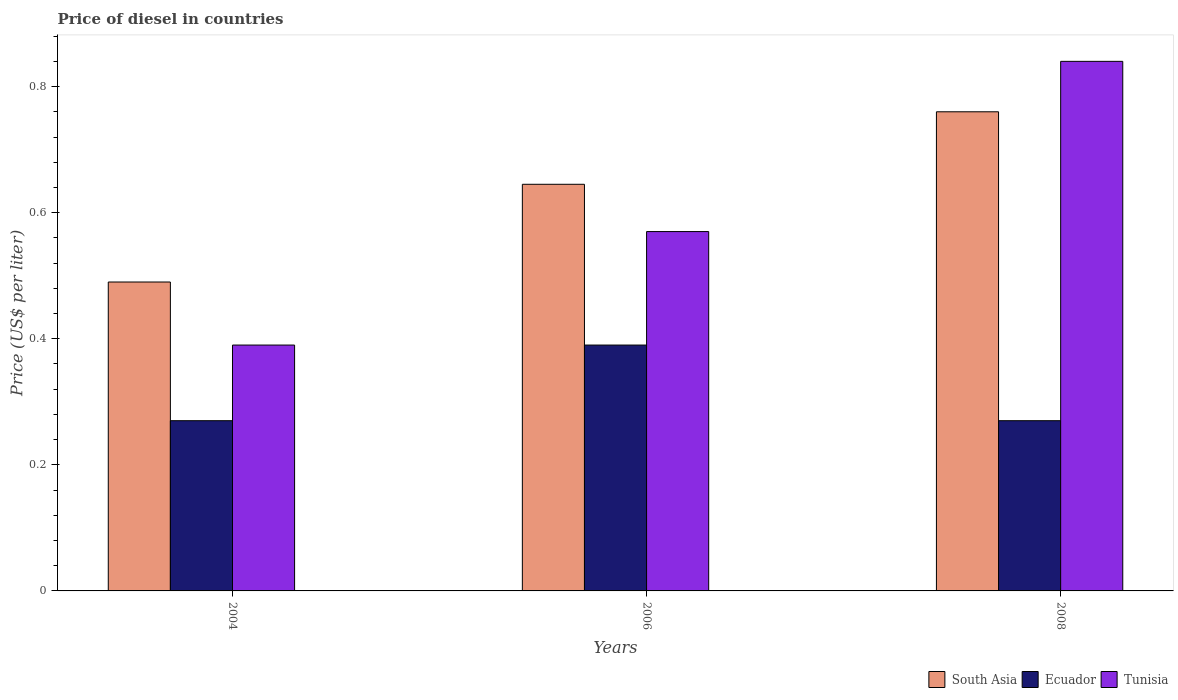How many different coloured bars are there?
Offer a terse response. 3. How many groups of bars are there?
Provide a succinct answer. 3. How many bars are there on the 1st tick from the left?
Keep it short and to the point. 3. What is the label of the 3rd group of bars from the left?
Your answer should be compact. 2008. What is the price of diesel in Ecuador in 2008?
Provide a succinct answer. 0.27. Across all years, what is the maximum price of diesel in Ecuador?
Provide a short and direct response. 0.39. Across all years, what is the minimum price of diesel in South Asia?
Keep it short and to the point. 0.49. In which year was the price of diesel in Tunisia maximum?
Offer a very short reply. 2008. In which year was the price of diesel in South Asia minimum?
Offer a very short reply. 2004. What is the total price of diesel in Ecuador in the graph?
Give a very brief answer. 0.93. What is the difference between the price of diesel in Ecuador in 2004 and that in 2006?
Offer a very short reply. -0.12. What is the difference between the price of diesel in South Asia in 2006 and the price of diesel in Tunisia in 2004?
Provide a short and direct response. 0.26. What is the average price of diesel in Tunisia per year?
Give a very brief answer. 0.6. In the year 2006, what is the difference between the price of diesel in South Asia and price of diesel in Tunisia?
Offer a very short reply. 0.08. In how many years, is the price of diesel in Ecuador greater than 0.28 US$?
Provide a short and direct response. 1. What is the ratio of the price of diesel in Tunisia in 2004 to that in 2006?
Provide a short and direct response. 0.68. What is the difference between the highest and the second highest price of diesel in Tunisia?
Provide a succinct answer. 0.27. What is the difference between the highest and the lowest price of diesel in Tunisia?
Provide a succinct answer. 0.45. Is the sum of the price of diesel in South Asia in 2004 and 2006 greater than the maximum price of diesel in Ecuador across all years?
Provide a succinct answer. Yes. What does the 3rd bar from the left in 2004 represents?
Offer a terse response. Tunisia. What does the 1st bar from the right in 2008 represents?
Your response must be concise. Tunisia. What is the difference between two consecutive major ticks on the Y-axis?
Provide a short and direct response. 0.2. Are the values on the major ticks of Y-axis written in scientific E-notation?
Make the answer very short. No. Does the graph contain grids?
Your response must be concise. No. What is the title of the graph?
Your answer should be compact. Price of diesel in countries. Does "Dominican Republic" appear as one of the legend labels in the graph?
Ensure brevity in your answer.  No. What is the label or title of the Y-axis?
Your answer should be compact. Price (US$ per liter). What is the Price (US$ per liter) of South Asia in 2004?
Ensure brevity in your answer.  0.49. What is the Price (US$ per liter) in Ecuador in 2004?
Give a very brief answer. 0.27. What is the Price (US$ per liter) in Tunisia in 2004?
Keep it short and to the point. 0.39. What is the Price (US$ per liter) of South Asia in 2006?
Your answer should be very brief. 0.65. What is the Price (US$ per liter) of Ecuador in 2006?
Your answer should be compact. 0.39. What is the Price (US$ per liter) in Tunisia in 2006?
Your answer should be very brief. 0.57. What is the Price (US$ per liter) of South Asia in 2008?
Ensure brevity in your answer.  0.76. What is the Price (US$ per liter) in Ecuador in 2008?
Offer a terse response. 0.27. What is the Price (US$ per liter) in Tunisia in 2008?
Give a very brief answer. 0.84. Across all years, what is the maximum Price (US$ per liter) of South Asia?
Your answer should be compact. 0.76. Across all years, what is the maximum Price (US$ per liter) of Ecuador?
Keep it short and to the point. 0.39. Across all years, what is the maximum Price (US$ per liter) of Tunisia?
Ensure brevity in your answer.  0.84. Across all years, what is the minimum Price (US$ per liter) of South Asia?
Your response must be concise. 0.49. Across all years, what is the minimum Price (US$ per liter) in Ecuador?
Offer a terse response. 0.27. Across all years, what is the minimum Price (US$ per liter) of Tunisia?
Your response must be concise. 0.39. What is the total Price (US$ per liter) of South Asia in the graph?
Offer a very short reply. 1.9. What is the total Price (US$ per liter) in Ecuador in the graph?
Offer a very short reply. 0.93. What is the total Price (US$ per liter) of Tunisia in the graph?
Provide a succinct answer. 1.8. What is the difference between the Price (US$ per liter) in South Asia in 2004 and that in 2006?
Make the answer very short. -0.15. What is the difference between the Price (US$ per liter) of Ecuador in 2004 and that in 2006?
Ensure brevity in your answer.  -0.12. What is the difference between the Price (US$ per liter) of Tunisia in 2004 and that in 2006?
Ensure brevity in your answer.  -0.18. What is the difference between the Price (US$ per liter) of South Asia in 2004 and that in 2008?
Offer a terse response. -0.27. What is the difference between the Price (US$ per liter) of Tunisia in 2004 and that in 2008?
Offer a terse response. -0.45. What is the difference between the Price (US$ per liter) in South Asia in 2006 and that in 2008?
Offer a very short reply. -0.12. What is the difference between the Price (US$ per liter) in Ecuador in 2006 and that in 2008?
Provide a succinct answer. 0.12. What is the difference between the Price (US$ per liter) in Tunisia in 2006 and that in 2008?
Make the answer very short. -0.27. What is the difference between the Price (US$ per liter) of South Asia in 2004 and the Price (US$ per liter) of Ecuador in 2006?
Give a very brief answer. 0.1. What is the difference between the Price (US$ per liter) in South Asia in 2004 and the Price (US$ per liter) in Tunisia in 2006?
Give a very brief answer. -0.08. What is the difference between the Price (US$ per liter) of South Asia in 2004 and the Price (US$ per liter) of Ecuador in 2008?
Offer a very short reply. 0.22. What is the difference between the Price (US$ per liter) of South Asia in 2004 and the Price (US$ per liter) of Tunisia in 2008?
Offer a terse response. -0.35. What is the difference between the Price (US$ per liter) of Ecuador in 2004 and the Price (US$ per liter) of Tunisia in 2008?
Give a very brief answer. -0.57. What is the difference between the Price (US$ per liter) of South Asia in 2006 and the Price (US$ per liter) of Tunisia in 2008?
Make the answer very short. -0.2. What is the difference between the Price (US$ per liter) in Ecuador in 2006 and the Price (US$ per liter) in Tunisia in 2008?
Your response must be concise. -0.45. What is the average Price (US$ per liter) of South Asia per year?
Give a very brief answer. 0.63. What is the average Price (US$ per liter) of Ecuador per year?
Provide a succinct answer. 0.31. In the year 2004, what is the difference between the Price (US$ per liter) in South Asia and Price (US$ per liter) in Ecuador?
Your answer should be compact. 0.22. In the year 2004, what is the difference between the Price (US$ per liter) of South Asia and Price (US$ per liter) of Tunisia?
Ensure brevity in your answer.  0.1. In the year 2004, what is the difference between the Price (US$ per liter) in Ecuador and Price (US$ per liter) in Tunisia?
Provide a succinct answer. -0.12. In the year 2006, what is the difference between the Price (US$ per liter) in South Asia and Price (US$ per liter) in Ecuador?
Your answer should be compact. 0.26. In the year 2006, what is the difference between the Price (US$ per liter) of South Asia and Price (US$ per liter) of Tunisia?
Make the answer very short. 0.07. In the year 2006, what is the difference between the Price (US$ per liter) of Ecuador and Price (US$ per liter) of Tunisia?
Keep it short and to the point. -0.18. In the year 2008, what is the difference between the Price (US$ per liter) in South Asia and Price (US$ per liter) in Ecuador?
Keep it short and to the point. 0.49. In the year 2008, what is the difference between the Price (US$ per liter) of South Asia and Price (US$ per liter) of Tunisia?
Your answer should be very brief. -0.08. In the year 2008, what is the difference between the Price (US$ per liter) in Ecuador and Price (US$ per liter) in Tunisia?
Your response must be concise. -0.57. What is the ratio of the Price (US$ per liter) of South Asia in 2004 to that in 2006?
Make the answer very short. 0.76. What is the ratio of the Price (US$ per liter) in Ecuador in 2004 to that in 2006?
Ensure brevity in your answer.  0.69. What is the ratio of the Price (US$ per liter) in Tunisia in 2004 to that in 2006?
Provide a succinct answer. 0.68. What is the ratio of the Price (US$ per liter) of South Asia in 2004 to that in 2008?
Provide a short and direct response. 0.64. What is the ratio of the Price (US$ per liter) in Tunisia in 2004 to that in 2008?
Ensure brevity in your answer.  0.46. What is the ratio of the Price (US$ per liter) of South Asia in 2006 to that in 2008?
Your response must be concise. 0.85. What is the ratio of the Price (US$ per liter) of Ecuador in 2006 to that in 2008?
Your answer should be very brief. 1.44. What is the ratio of the Price (US$ per liter) of Tunisia in 2006 to that in 2008?
Make the answer very short. 0.68. What is the difference between the highest and the second highest Price (US$ per liter) of South Asia?
Make the answer very short. 0.12. What is the difference between the highest and the second highest Price (US$ per liter) in Ecuador?
Make the answer very short. 0.12. What is the difference between the highest and the second highest Price (US$ per liter) of Tunisia?
Your answer should be very brief. 0.27. What is the difference between the highest and the lowest Price (US$ per liter) in South Asia?
Offer a very short reply. 0.27. What is the difference between the highest and the lowest Price (US$ per liter) of Ecuador?
Your response must be concise. 0.12. What is the difference between the highest and the lowest Price (US$ per liter) of Tunisia?
Your response must be concise. 0.45. 